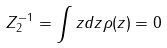<formula> <loc_0><loc_0><loc_500><loc_500>Z _ { 2 } ^ { - 1 } = \int z d z \rho ( z ) = 0</formula> 